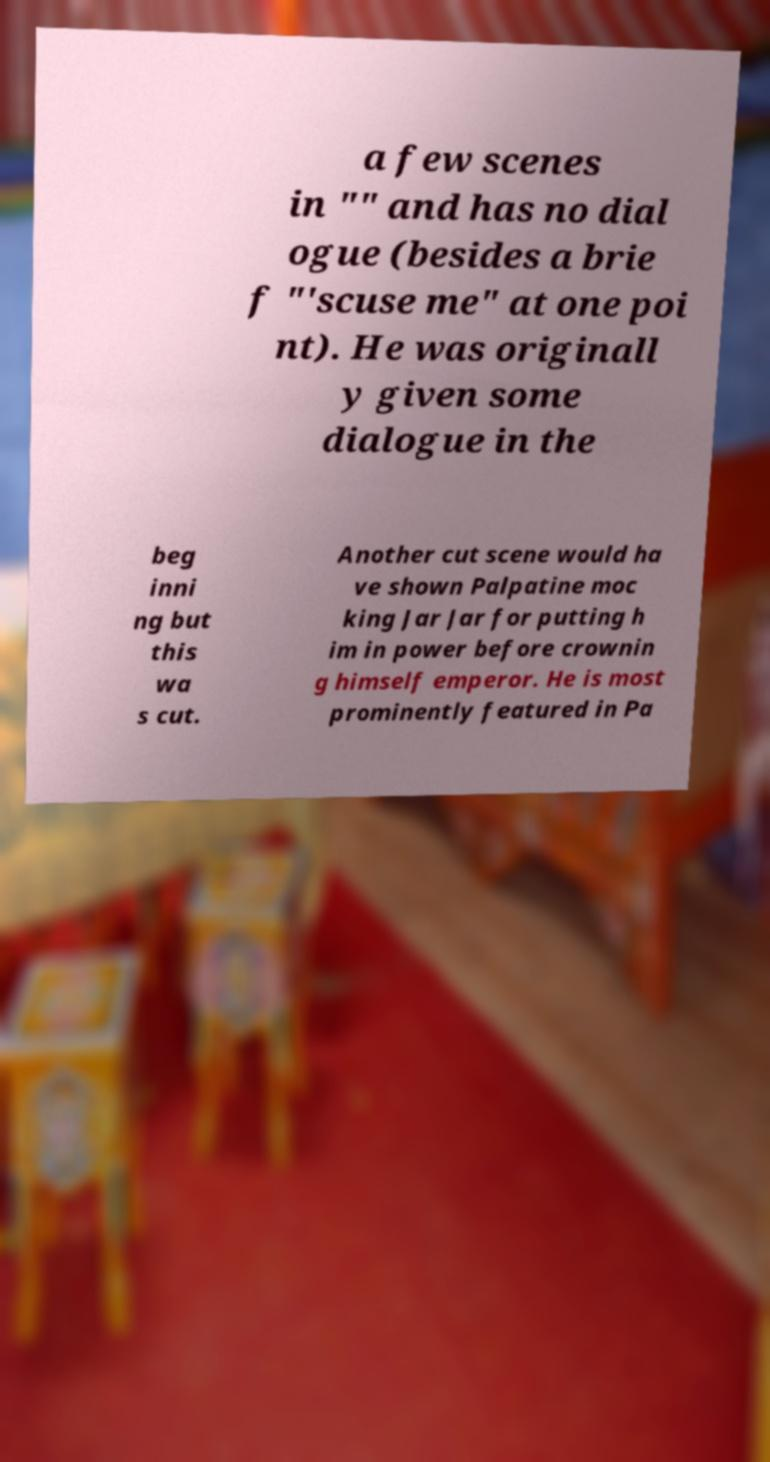For documentation purposes, I need the text within this image transcribed. Could you provide that? a few scenes in "" and has no dial ogue (besides a brie f "'scuse me" at one poi nt). He was originall y given some dialogue in the beg inni ng but this wa s cut. Another cut scene would ha ve shown Palpatine moc king Jar Jar for putting h im in power before crownin g himself emperor. He is most prominently featured in Pa 